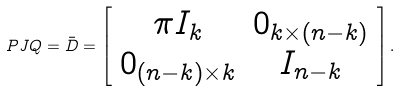Convert formula to latex. <formula><loc_0><loc_0><loc_500><loc_500>P J Q = \bar { D } = \left [ \begin{array} { c c } \pi I _ { k } & 0 _ { k \times ( n - k ) } \\ 0 _ { ( n - k ) \times k } & I _ { n - k } \end{array} \right ] .</formula> 